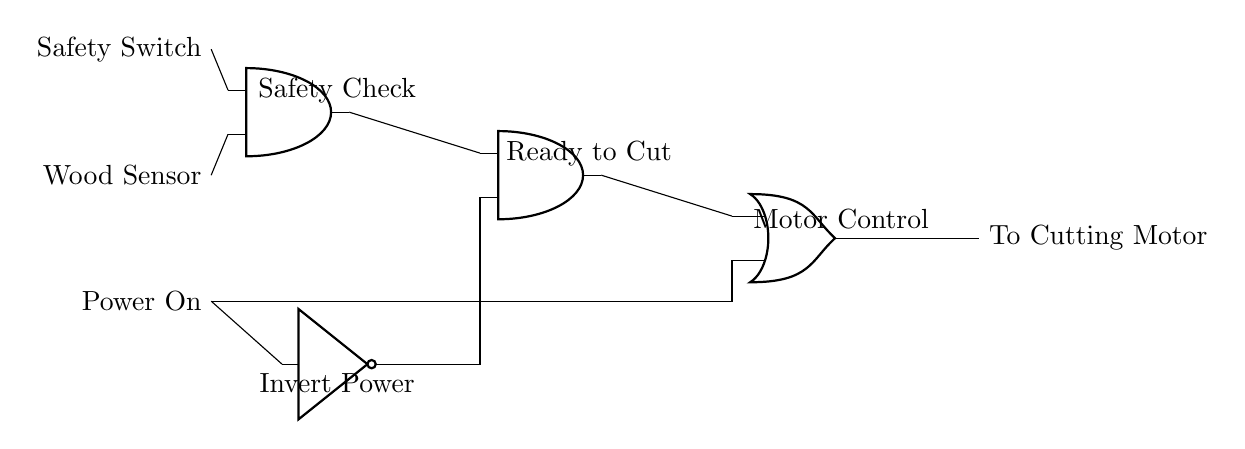What are the three inputs to the circuit? The three inputs are the Safety Switch, Wood Sensor, and Power On. These inputs are represented on the left side of the diagram, and each is labeled accordingly.
Answer: Safety Switch, Wood Sensor, Power On What type of logic gate is used to implement a safety check? The safety check is implemented using an AND gate. This is indicated by the label next to the AND gate in the circuit, which is specifically marked as "Safety Check."
Answer: AND gate How many AND gates are present in the circuit? There are two AND gates in the circuit, as visible in the diagram with each gate individually marked.
Answer: 2 What does the NOT gate do in this circuit? The NOT gate inverts the Power On input, meaning it produces an output that is the opposite state of the input it receives. This inversion is crucial for the logic of controlling the cutting motor.
Answer: Inverts Power What is the output of the circuit? The output of the circuit is directed to the Cutting Motor. This is labeled on the right side of the circuit diagram, where the connection leads out.
Answer: To Cutting Motor Which logic operation is performed last in the circuit? The final logic operation in the circuit is an OR operation, which combines the outputs from the two different inputs (the AND gate outputs and the inverted Power On). This determines whether to activate the Cutting Motor.
Answer: OR operation How does the circuit control the cutting motor? The circuit controls the cutting motor by processing the inputs through logical operations—specifically, it outputs to the motor if either the AND gate output conditions are met or if Power On is active (inverted). This dual-condition setup ensures safe operation.
Answer: Dual-condition logic 